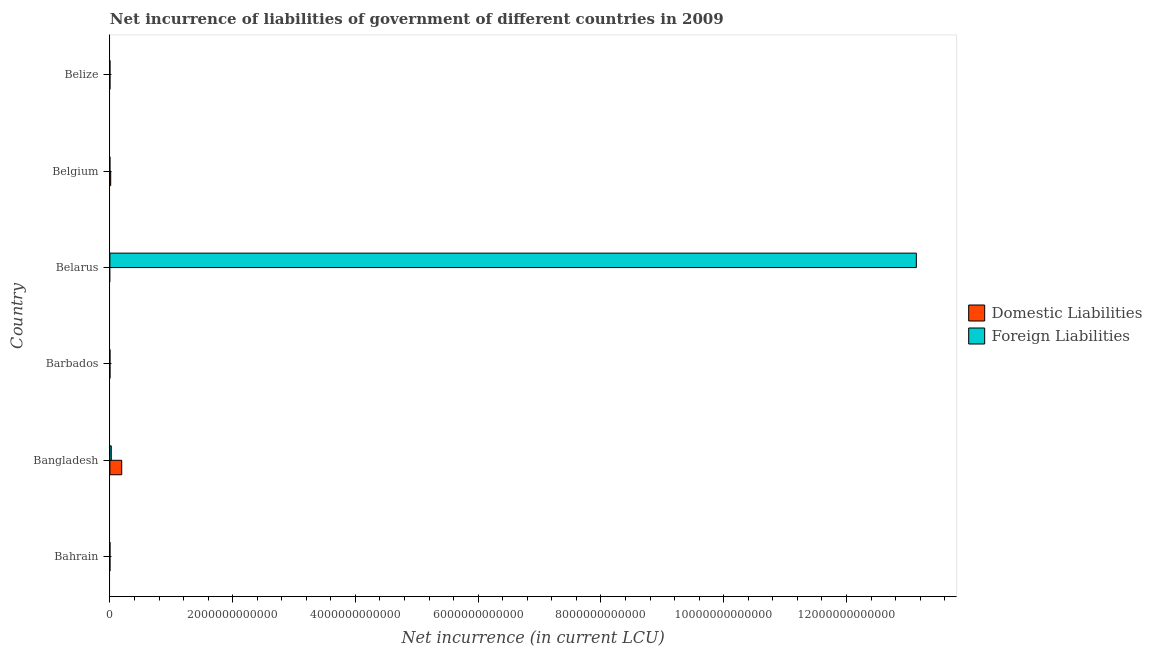How many different coloured bars are there?
Keep it short and to the point. 2. How many bars are there on the 2nd tick from the top?
Offer a very short reply. 1. How many bars are there on the 2nd tick from the bottom?
Provide a short and direct response. 2. What is the label of the 5th group of bars from the top?
Provide a short and direct response. Bangladesh. In how many cases, is the number of bars for a given country not equal to the number of legend labels?
Ensure brevity in your answer.  2. What is the net incurrence of domestic liabilities in Barbados?
Your answer should be very brief. 5.80e+08. Across all countries, what is the maximum net incurrence of domestic liabilities?
Make the answer very short. 1.93e+11. In which country was the net incurrence of foreign liabilities maximum?
Your response must be concise. Belarus. What is the total net incurrence of domestic liabilities in the graph?
Ensure brevity in your answer.  2.07e+11. What is the difference between the net incurrence of foreign liabilities in Bahrain and that in Belize?
Offer a very short reply. 2.93e+08. What is the difference between the net incurrence of domestic liabilities in Belgium and the net incurrence of foreign liabilities in Belize?
Keep it short and to the point. 1.31e+1. What is the average net incurrence of foreign liabilities per country?
Provide a short and direct response. 2.19e+12. What is the difference between the net incurrence of foreign liabilities and net incurrence of domestic liabilities in Bangladesh?
Keep it short and to the point. -1.70e+11. In how many countries, is the net incurrence of foreign liabilities greater than 12400000000000 LCU?
Provide a succinct answer. 1. What is the ratio of the net incurrence of domestic liabilities in Bahrain to that in Belgium?
Offer a very short reply. 0.03. Is the net incurrence of domestic liabilities in Belgium less than that in Belize?
Keep it short and to the point. No. What is the difference between the highest and the second highest net incurrence of domestic liabilities?
Provide a succinct answer. 1.80e+11. What is the difference between the highest and the lowest net incurrence of foreign liabilities?
Offer a terse response. 1.31e+13. In how many countries, is the net incurrence of foreign liabilities greater than the average net incurrence of foreign liabilities taken over all countries?
Give a very brief answer. 1. How many bars are there?
Keep it short and to the point. 10. How many countries are there in the graph?
Offer a very short reply. 6. What is the difference between two consecutive major ticks on the X-axis?
Ensure brevity in your answer.  2.00e+12. Does the graph contain grids?
Ensure brevity in your answer.  No. Where does the legend appear in the graph?
Your answer should be compact. Center right. What is the title of the graph?
Keep it short and to the point. Net incurrence of liabilities of government of different countries in 2009. What is the label or title of the X-axis?
Give a very brief answer. Net incurrence (in current LCU). What is the label or title of the Y-axis?
Ensure brevity in your answer.  Country. What is the Net incurrence (in current LCU) in Domestic Liabilities in Bahrain?
Provide a short and direct response. 3.55e+08. What is the Net incurrence (in current LCU) of Foreign Liabilities in Bahrain?
Keep it short and to the point. 3.09e+08. What is the Net incurrence (in current LCU) in Domestic Liabilities in Bangladesh?
Offer a terse response. 1.93e+11. What is the Net incurrence (in current LCU) in Foreign Liabilities in Bangladesh?
Offer a terse response. 2.24e+1. What is the Net incurrence (in current LCU) in Domestic Liabilities in Barbados?
Provide a short and direct response. 5.80e+08. What is the Net incurrence (in current LCU) of Foreign Liabilities in Barbados?
Your answer should be compact. 3.75e+08. What is the Net incurrence (in current LCU) in Foreign Liabilities in Belarus?
Keep it short and to the point. 1.31e+13. What is the Net incurrence (in current LCU) of Domestic Liabilities in Belgium?
Give a very brief answer. 1.31e+1. What is the Net incurrence (in current LCU) of Domestic Liabilities in Belize?
Provide a succinct answer. 4.26e+06. What is the Net incurrence (in current LCU) of Foreign Liabilities in Belize?
Your response must be concise. 1.56e+07. Across all countries, what is the maximum Net incurrence (in current LCU) in Domestic Liabilities?
Your answer should be very brief. 1.93e+11. Across all countries, what is the maximum Net incurrence (in current LCU) in Foreign Liabilities?
Your response must be concise. 1.31e+13. Across all countries, what is the minimum Net incurrence (in current LCU) of Foreign Liabilities?
Provide a short and direct response. 0. What is the total Net incurrence (in current LCU) in Domestic Liabilities in the graph?
Keep it short and to the point. 2.07e+11. What is the total Net incurrence (in current LCU) of Foreign Liabilities in the graph?
Offer a very short reply. 1.32e+13. What is the difference between the Net incurrence (in current LCU) of Domestic Liabilities in Bahrain and that in Bangladesh?
Make the answer very short. -1.92e+11. What is the difference between the Net incurrence (in current LCU) of Foreign Liabilities in Bahrain and that in Bangladesh?
Provide a succinct answer. -2.21e+1. What is the difference between the Net incurrence (in current LCU) of Domestic Liabilities in Bahrain and that in Barbados?
Provide a short and direct response. -2.25e+08. What is the difference between the Net incurrence (in current LCU) of Foreign Liabilities in Bahrain and that in Barbados?
Provide a short and direct response. -6.61e+07. What is the difference between the Net incurrence (in current LCU) of Foreign Liabilities in Bahrain and that in Belarus?
Ensure brevity in your answer.  -1.31e+13. What is the difference between the Net incurrence (in current LCU) of Domestic Liabilities in Bahrain and that in Belgium?
Provide a short and direct response. -1.28e+1. What is the difference between the Net incurrence (in current LCU) in Domestic Liabilities in Bahrain and that in Belize?
Offer a very short reply. 3.51e+08. What is the difference between the Net incurrence (in current LCU) of Foreign Liabilities in Bahrain and that in Belize?
Provide a short and direct response. 2.93e+08. What is the difference between the Net incurrence (in current LCU) in Domestic Liabilities in Bangladesh and that in Barbados?
Your answer should be compact. 1.92e+11. What is the difference between the Net incurrence (in current LCU) in Foreign Liabilities in Bangladesh and that in Barbados?
Give a very brief answer. 2.20e+1. What is the difference between the Net incurrence (in current LCU) in Foreign Liabilities in Bangladesh and that in Belarus?
Ensure brevity in your answer.  -1.31e+13. What is the difference between the Net incurrence (in current LCU) in Domestic Liabilities in Bangladesh and that in Belgium?
Give a very brief answer. 1.80e+11. What is the difference between the Net incurrence (in current LCU) of Domestic Liabilities in Bangladesh and that in Belize?
Your answer should be compact. 1.93e+11. What is the difference between the Net incurrence (in current LCU) in Foreign Liabilities in Bangladesh and that in Belize?
Keep it short and to the point. 2.24e+1. What is the difference between the Net incurrence (in current LCU) of Foreign Liabilities in Barbados and that in Belarus?
Give a very brief answer. -1.31e+13. What is the difference between the Net incurrence (in current LCU) in Domestic Liabilities in Barbados and that in Belgium?
Offer a very short reply. -1.25e+1. What is the difference between the Net incurrence (in current LCU) of Domestic Liabilities in Barbados and that in Belize?
Your answer should be compact. 5.76e+08. What is the difference between the Net incurrence (in current LCU) in Foreign Liabilities in Barbados and that in Belize?
Offer a very short reply. 3.59e+08. What is the difference between the Net incurrence (in current LCU) in Foreign Liabilities in Belarus and that in Belize?
Your response must be concise. 1.31e+13. What is the difference between the Net incurrence (in current LCU) in Domestic Liabilities in Belgium and that in Belize?
Offer a terse response. 1.31e+1. What is the difference between the Net incurrence (in current LCU) in Domestic Liabilities in Bahrain and the Net incurrence (in current LCU) in Foreign Liabilities in Bangladesh?
Make the answer very short. -2.20e+1. What is the difference between the Net incurrence (in current LCU) of Domestic Liabilities in Bahrain and the Net incurrence (in current LCU) of Foreign Liabilities in Barbados?
Make the answer very short. -1.94e+07. What is the difference between the Net incurrence (in current LCU) in Domestic Liabilities in Bahrain and the Net incurrence (in current LCU) in Foreign Liabilities in Belarus?
Your answer should be very brief. -1.31e+13. What is the difference between the Net incurrence (in current LCU) of Domestic Liabilities in Bahrain and the Net incurrence (in current LCU) of Foreign Liabilities in Belize?
Your response must be concise. 3.40e+08. What is the difference between the Net incurrence (in current LCU) of Domestic Liabilities in Bangladesh and the Net incurrence (in current LCU) of Foreign Liabilities in Barbados?
Your response must be concise. 1.92e+11. What is the difference between the Net incurrence (in current LCU) in Domestic Liabilities in Bangladesh and the Net incurrence (in current LCU) in Foreign Liabilities in Belarus?
Provide a short and direct response. -1.29e+13. What is the difference between the Net incurrence (in current LCU) of Domestic Liabilities in Bangladesh and the Net incurrence (in current LCU) of Foreign Liabilities in Belize?
Offer a very short reply. 1.93e+11. What is the difference between the Net incurrence (in current LCU) in Domestic Liabilities in Barbados and the Net incurrence (in current LCU) in Foreign Liabilities in Belarus?
Offer a terse response. -1.31e+13. What is the difference between the Net incurrence (in current LCU) of Domestic Liabilities in Barbados and the Net incurrence (in current LCU) of Foreign Liabilities in Belize?
Your response must be concise. 5.65e+08. What is the difference between the Net incurrence (in current LCU) of Domestic Liabilities in Belgium and the Net incurrence (in current LCU) of Foreign Liabilities in Belize?
Provide a short and direct response. 1.31e+1. What is the average Net incurrence (in current LCU) in Domestic Liabilities per country?
Keep it short and to the point. 3.45e+1. What is the average Net incurrence (in current LCU) in Foreign Liabilities per country?
Make the answer very short. 2.19e+12. What is the difference between the Net incurrence (in current LCU) in Domestic Liabilities and Net incurrence (in current LCU) in Foreign Liabilities in Bahrain?
Provide a succinct answer. 4.67e+07. What is the difference between the Net incurrence (in current LCU) in Domestic Liabilities and Net incurrence (in current LCU) in Foreign Liabilities in Bangladesh?
Ensure brevity in your answer.  1.70e+11. What is the difference between the Net incurrence (in current LCU) in Domestic Liabilities and Net incurrence (in current LCU) in Foreign Liabilities in Barbados?
Your response must be concise. 2.05e+08. What is the difference between the Net incurrence (in current LCU) of Domestic Liabilities and Net incurrence (in current LCU) of Foreign Liabilities in Belize?
Provide a succinct answer. -1.14e+07. What is the ratio of the Net incurrence (in current LCU) of Domestic Liabilities in Bahrain to that in Bangladesh?
Your answer should be very brief. 0. What is the ratio of the Net incurrence (in current LCU) in Foreign Liabilities in Bahrain to that in Bangladesh?
Your answer should be very brief. 0.01. What is the ratio of the Net incurrence (in current LCU) in Domestic Liabilities in Bahrain to that in Barbados?
Provide a short and direct response. 0.61. What is the ratio of the Net incurrence (in current LCU) in Foreign Liabilities in Bahrain to that in Barbados?
Your answer should be very brief. 0.82. What is the ratio of the Net incurrence (in current LCU) in Foreign Liabilities in Bahrain to that in Belarus?
Ensure brevity in your answer.  0. What is the ratio of the Net incurrence (in current LCU) of Domestic Liabilities in Bahrain to that in Belgium?
Offer a terse response. 0.03. What is the ratio of the Net incurrence (in current LCU) of Domestic Liabilities in Bahrain to that in Belize?
Ensure brevity in your answer.  83.48. What is the ratio of the Net incurrence (in current LCU) of Foreign Liabilities in Bahrain to that in Belize?
Offer a terse response. 19.77. What is the ratio of the Net incurrence (in current LCU) in Domestic Liabilities in Bangladesh to that in Barbados?
Keep it short and to the point. 332.07. What is the ratio of the Net incurrence (in current LCU) in Foreign Liabilities in Bangladesh to that in Barbados?
Your answer should be compact. 59.69. What is the ratio of the Net incurrence (in current LCU) of Foreign Liabilities in Bangladesh to that in Belarus?
Ensure brevity in your answer.  0. What is the ratio of the Net incurrence (in current LCU) in Domestic Liabilities in Bangladesh to that in Belgium?
Provide a succinct answer. 14.68. What is the ratio of the Net incurrence (in current LCU) of Domestic Liabilities in Bangladesh to that in Belize?
Your answer should be very brief. 4.53e+04. What is the ratio of the Net incurrence (in current LCU) of Foreign Liabilities in Bangladesh to that in Belize?
Make the answer very short. 1432.39. What is the ratio of the Net incurrence (in current LCU) of Domestic Liabilities in Barbados to that in Belgium?
Your response must be concise. 0.04. What is the ratio of the Net incurrence (in current LCU) of Domestic Liabilities in Barbados to that in Belize?
Offer a very short reply. 136.31. What is the ratio of the Net incurrence (in current LCU) in Foreign Liabilities in Barbados to that in Belize?
Make the answer very short. 24. What is the ratio of the Net incurrence (in current LCU) in Foreign Liabilities in Belarus to that in Belize?
Provide a succinct answer. 8.41e+05. What is the ratio of the Net incurrence (in current LCU) in Domestic Liabilities in Belgium to that in Belize?
Ensure brevity in your answer.  3084.07. What is the difference between the highest and the second highest Net incurrence (in current LCU) in Domestic Liabilities?
Give a very brief answer. 1.80e+11. What is the difference between the highest and the second highest Net incurrence (in current LCU) in Foreign Liabilities?
Give a very brief answer. 1.31e+13. What is the difference between the highest and the lowest Net incurrence (in current LCU) of Domestic Liabilities?
Give a very brief answer. 1.93e+11. What is the difference between the highest and the lowest Net incurrence (in current LCU) of Foreign Liabilities?
Your answer should be very brief. 1.31e+13. 